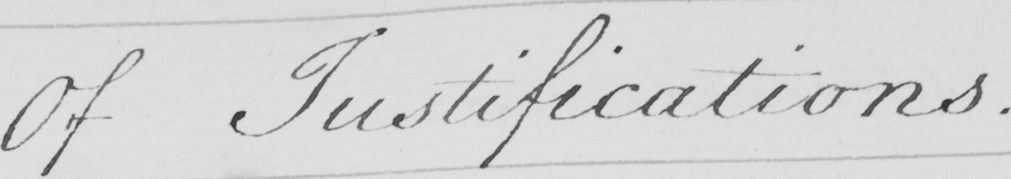Can you tell me what this handwritten text says? Of Justifications . 